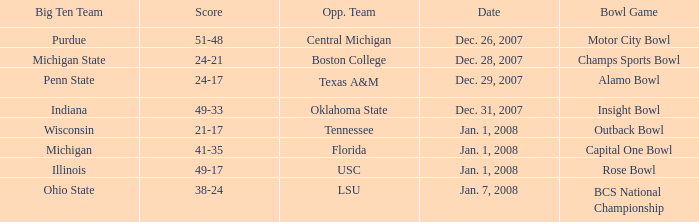Which bowl game took place on december 26, 2007? Motor City Bowl. 